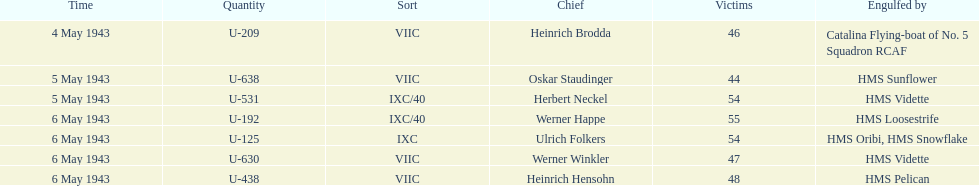What was the number of casualties on may 4 1943? 46. Would you mind parsing the complete table? {'header': ['Time', 'Quantity', 'Sort', 'Chief', 'Victims', 'Engulfed by'], 'rows': [['4 May 1943', 'U-209', 'VIIC', 'Heinrich Brodda', '46', 'Catalina Flying-boat of No. 5 Squadron RCAF'], ['5 May 1943', 'U-638', 'VIIC', 'Oskar Staudinger', '44', 'HMS Sunflower'], ['5 May 1943', 'U-531', 'IXC/40', 'Herbert Neckel', '54', 'HMS Vidette'], ['6 May 1943', 'U-192', 'IXC/40', 'Werner Happe', '55', 'HMS Loosestrife'], ['6 May 1943', 'U-125', 'IXC', 'Ulrich Folkers', '54', 'HMS Oribi, HMS Snowflake'], ['6 May 1943', 'U-630', 'VIIC', 'Werner Winkler', '47', 'HMS Vidette'], ['6 May 1943', 'U-438', 'VIIC', 'Heinrich Hensohn', '48', 'HMS Pelican']]} 